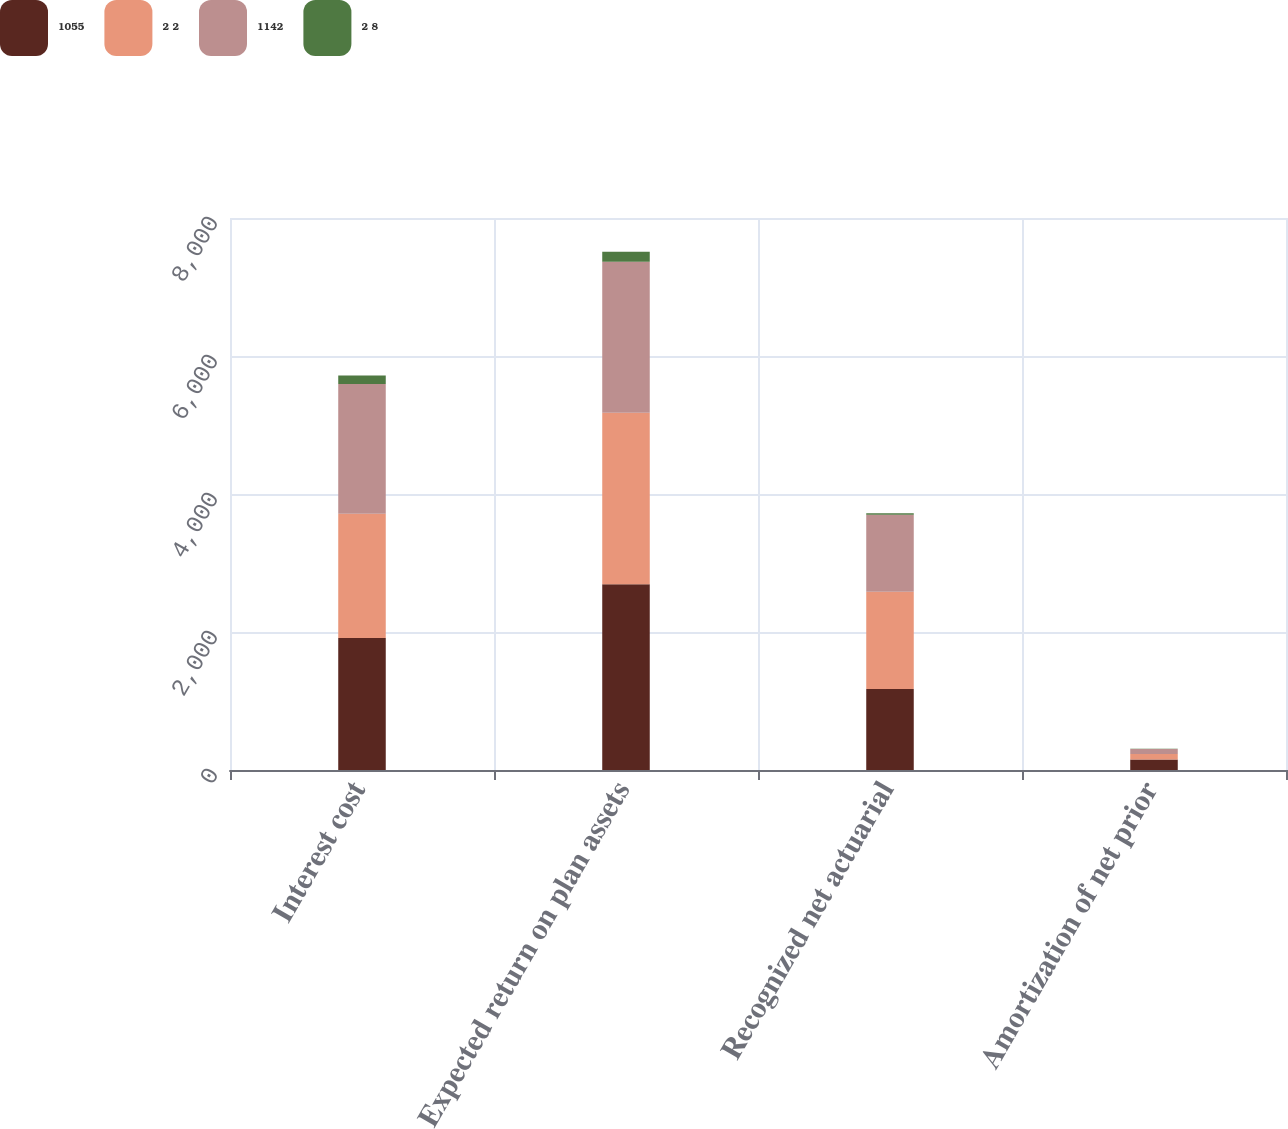Convert chart. <chart><loc_0><loc_0><loc_500><loc_500><stacked_bar_chart><ecel><fcel>Interest cost<fcel>Expected return on plan assets<fcel>Recognized net actuarial<fcel>Amortization of net prior<nl><fcel>1055<fcel>1912<fcel>2693<fcel>1173<fcel>151<nl><fcel>2 2<fcel>1800<fcel>2485<fcel>1410<fcel>81<nl><fcel>1142<fcel>1884<fcel>2187<fcel>1116<fcel>73<nl><fcel>2 8<fcel>123<fcel>146<fcel>23<fcel>4<nl></chart> 